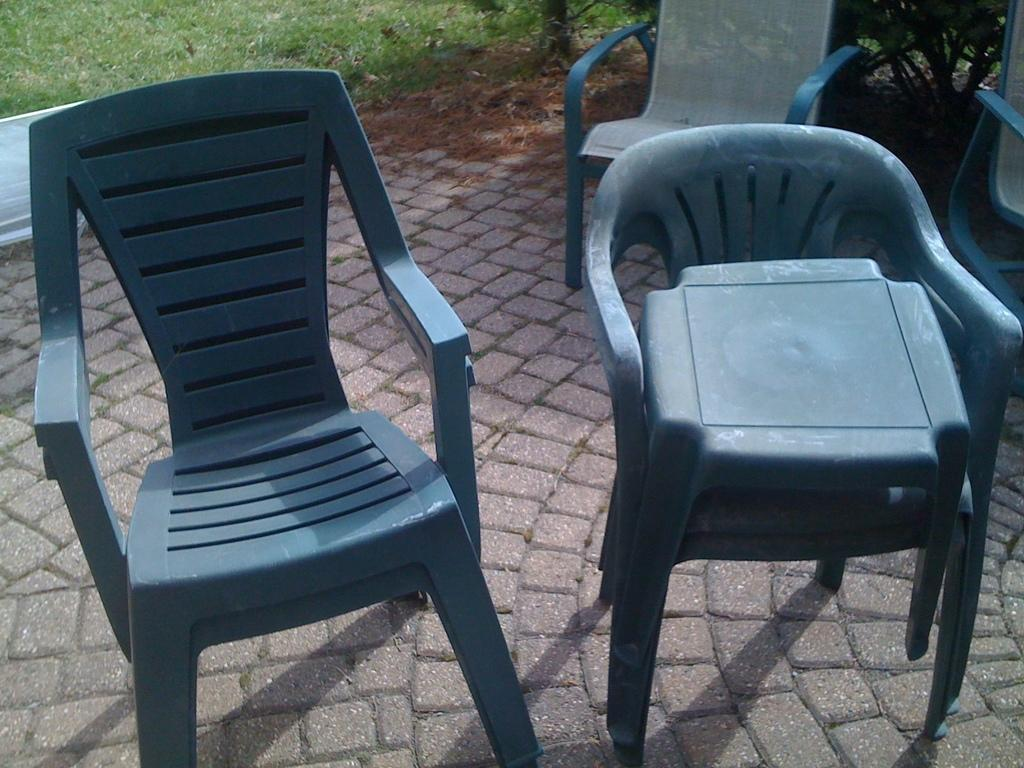What type of furniture is present in the image? There are chairs in the image. What can be seen in the background of the image? There is grass visible in the background of the image. What is the surface at the bottom of the image? There is a floor at the bottom of the image. What type of brush is being used to play baseball in the image? There is no brush or baseball present in the image. 